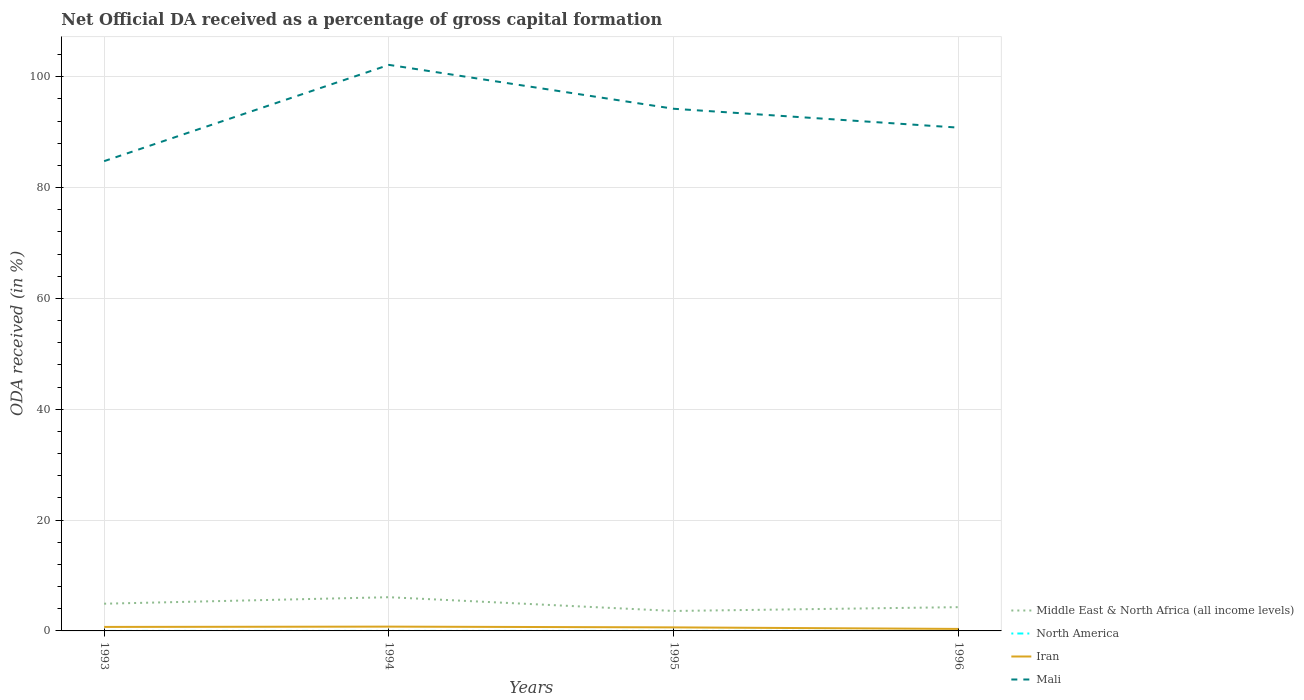Does the line corresponding to Middle East & North Africa (all income levels) intersect with the line corresponding to North America?
Your response must be concise. No. Across all years, what is the maximum net ODA received in Iran?
Give a very brief answer. 0.36. What is the total net ODA received in Middle East & North Africa (all income levels) in the graph?
Give a very brief answer. -1.17. What is the difference between the highest and the second highest net ODA received in Iran?
Your answer should be compact. 0.41. Is the net ODA received in Iran strictly greater than the net ODA received in North America over the years?
Keep it short and to the point. No. What is the difference between two consecutive major ticks on the Y-axis?
Provide a short and direct response. 20. Are the values on the major ticks of Y-axis written in scientific E-notation?
Make the answer very short. No. Does the graph contain any zero values?
Give a very brief answer. Yes. Where does the legend appear in the graph?
Your answer should be very brief. Bottom right. What is the title of the graph?
Keep it short and to the point. Net Official DA received as a percentage of gross capital formation. Does "Curacao" appear as one of the legend labels in the graph?
Give a very brief answer. No. What is the label or title of the Y-axis?
Ensure brevity in your answer.  ODA received (in %). What is the ODA received (in %) in Middle East & North Africa (all income levels) in 1993?
Offer a terse response. 4.91. What is the ODA received (in %) of Iran in 1993?
Make the answer very short. 0.72. What is the ODA received (in %) of Mali in 1993?
Your response must be concise. 84.77. What is the ODA received (in %) in Middle East & North Africa (all income levels) in 1994?
Provide a succinct answer. 6.08. What is the ODA received (in %) in North America in 1994?
Your answer should be compact. 0. What is the ODA received (in %) of Iran in 1994?
Make the answer very short. 0.77. What is the ODA received (in %) in Mali in 1994?
Give a very brief answer. 102.15. What is the ODA received (in %) in Middle East & North Africa (all income levels) in 1995?
Provide a succinct answer. 3.6. What is the ODA received (in %) of Iran in 1995?
Keep it short and to the point. 0.64. What is the ODA received (in %) in Mali in 1995?
Your response must be concise. 94.22. What is the ODA received (in %) of Middle East & North Africa (all income levels) in 1996?
Provide a succinct answer. 4.29. What is the ODA received (in %) of Iran in 1996?
Provide a succinct answer. 0.36. What is the ODA received (in %) of Mali in 1996?
Ensure brevity in your answer.  90.82. Across all years, what is the maximum ODA received (in %) in Middle East & North Africa (all income levels)?
Keep it short and to the point. 6.08. Across all years, what is the maximum ODA received (in %) of Iran?
Offer a very short reply. 0.77. Across all years, what is the maximum ODA received (in %) in Mali?
Your answer should be very brief. 102.15. Across all years, what is the minimum ODA received (in %) of Middle East & North Africa (all income levels)?
Your answer should be compact. 3.6. Across all years, what is the minimum ODA received (in %) of Iran?
Provide a succinct answer. 0.36. Across all years, what is the minimum ODA received (in %) in Mali?
Keep it short and to the point. 84.77. What is the total ODA received (in %) in Middle East & North Africa (all income levels) in the graph?
Keep it short and to the point. 18.89. What is the total ODA received (in %) of Iran in the graph?
Offer a terse response. 2.5. What is the total ODA received (in %) of Mali in the graph?
Provide a succinct answer. 371.96. What is the difference between the ODA received (in %) in Middle East & North Africa (all income levels) in 1993 and that in 1994?
Your answer should be compact. -1.17. What is the difference between the ODA received (in %) in Iran in 1993 and that in 1994?
Provide a succinct answer. -0.05. What is the difference between the ODA received (in %) of Mali in 1993 and that in 1994?
Provide a short and direct response. -17.37. What is the difference between the ODA received (in %) of Middle East & North Africa (all income levels) in 1993 and that in 1995?
Your response must be concise. 1.31. What is the difference between the ODA received (in %) in Iran in 1993 and that in 1995?
Offer a terse response. 0.08. What is the difference between the ODA received (in %) of Mali in 1993 and that in 1995?
Ensure brevity in your answer.  -9.45. What is the difference between the ODA received (in %) in Middle East & North Africa (all income levels) in 1993 and that in 1996?
Your answer should be compact. 0.62. What is the difference between the ODA received (in %) of Iran in 1993 and that in 1996?
Your answer should be compact. 0.36. What is the difference between the ODA received (in %) in Mali in 1993 and that in 1996?
Provide a short and direct response. -6.05. What is the difference between the ODA received (in %) of Middle East & North Africa (all income levels) in 1994 and that in 1995?
Make the answer very short. 2.48. What is the difference between the ODA received (in %) in Iran in 1994 and that in 1995?
Offer a very short reply. 0.13. What is the difference between the ODA received (in %) in Mali in 1994 and that in 1995?
Your answer should be very brief. 7.92. What is the difference between the ODA received (in %) of Middle East & North Africa (all income levels) in 1994 and that in 1996?
Ensure brevity in your answer.  1.8. What is the difference between the ODA received (in %) in Iran in 1994 and that in 1996?
Your answer should be very brief. 0.41. What is the difference between the ODA received (in %) in Mali in 1994 and that in 1996?
Provide a short and direct response. 11.33. What is the difference between the ODA received (in %) of Middle East & North Africa (all income levels) in 1995 and that in 1996?
Make the answer very short. -0.69. What is the difference between the ODA received (in %) of Iran in 1995 and that in 1996?
Make the answer very short. 0.28. What is the difference between the ODA received (in %) of Mali in 1995 and that in 1996?
Offer a terse response. 3.41. What is the difference between the ODA received (in %) of Middle East & North Africa (all income levels) in 1993 and the ODA received (in %) of Iran in 1994?
Your answer should be very brief. 4.14. What is the difference between the ODA received (in %) in Middle East & North Africa (all income levels) in 1993 and the ODA received (in %) in Mali in 1994?
Your response must be concise. -97.23. What is the difference between the ODA received (in %) in Iran in 1993 and the ODA received (in %) in Mali in 1994?
Ensure brevity in your answer.  -101.42. What is the difference between the ODA received (in %) in Middle East & North Africa (all income levels) in 1993 and the ODA received (in %) in Iran in 1995?
Make the answer very short. 4.27. What is the difference between the ODA received (in %) of Middle East & North Africa (all income levels) in 1993 and the ODA received (in %) of Mali in 1995?
Your answer should be very brief. -89.31. What is the difference between the ODA received (in %) of Iran in 1993 and the ODA received (in %) of Mali in 1995?
Make the answer very short. -93.5. What is the difference between the ODA received (in %) of Middle East & North Africa (all income levels) in 1993 and the ODA received (in %) of Iran in 1996?
Provide a short and direct response. 4.55. What is the difference between the ODA received (in %) in Middle East & North Africa (all income levels) in 1993 and the ODA received (in %) in Mali in 1996?
Your answer should be very brief. -85.91. What is the difference between the ODA received (in %) in Iran in 1993 and the ODA received (in %) in Mali in 1996?
Keep it short and to the point. -90.1. What is the difference between the ODA received (in %) in Middle East & North Africa (all income levels) in 1994 and the ODA received (in %) in Iran in 1995?
Make the answer very short. 5.44. What is the difference between the ODA received (in %) of Middle East & North Africa (all income levels) in 1994 and the ODA received (in %) of Mali in 1995?
Your response must be concise. -88.14. What is the difference between the ODA received (in %) of Iran in 1994 and the ODA received (in %) of Mali in 1995?
Provide a succinct answer. -93.45. What is the difference between the ODA received (in %) in Middle East & North Africa (all income levels) in 1994 and the ODA received (in %) in Iran in 1996?
Make the answer very short. 5.72. What is the difference between the ODA received (in %) of Middle East & North Africa (all income levels) in 1994 and the ODA received (in %) of Mali in 1996?
Give a very brief answer. -84.73. What is the difference between the ODA received (in %) in Iran in 1994 and the ODA received (in %) in Mali in 1996?
Your answer should be very brief. -90.04. What is the difference between the ODA received (in %) in Middle East & North Africa (all income levels) in 1995 and the ODA received (in %) in Iran in 1996?
Your answer should be compact. 3.24. What is the difference between the ODA received (in %) of Middle East & North Africa (all income levels) in 1995 and the ODA received (in %) of Mali in 1996?
Ensure brevity in your answer.  -87.22. What is the difference between the ODA received (in %) of Iran in 1995 and the ODA received (in %) of Mali in 1996?
Offer a terse response. -90.18. What is the average ODA received (in %) in Middle East & North Africa (all income levels) per year?
Offer a terse response. 4.72. What is the average ODA received (in %) of North America per year?
Make the answer very short. 0. What is the average ODA received (in %) of Iran per year?
Offer a terse response. 0.62. What is the average ODA received (in %) in Mali per year?
Provide a succinct answer. 92.99. In the year 1993, what is the difference between the ODA received (in %) in Middle East & North Africa (all income levels) and ODA received (in %) in Iran?
Ensure brevity in your answer.  4.19. In the year 1993, what is the difference between the ODA received (in %) of Middle East & North Africa (all income levels) and ODA received (in %) of Mali?
Provide a succinct answer. -79.86. In the year 1993, what is the difference between the ODA received (in %) of Iran and ODA received (in %) of Mali?
Offer a very short reply. -84.05. In the year 1994, what is the difference between the ODA received (in %) of Middle East & North Africa (all income levels) and ODA received (in %) of Iran?
Your answer should be very brief. 5.31. In the year 1994, what is the difference between the ODA received (in %) in Middle East & North Africa (all income levels) and ODA received (in %) in Mali?
Your answer should be compact. -96.06. In the year 1994, what is the difference between the ODA received (in %) of Iran and ODA received (in %) of Mali?
Give a very brief answer. -101.37. In the year 1995, what is the difference between the ODA received (in %) of Middle East & North Africa (all income levels) and ODA received (in %) of Iran?
Your answer should be compact. 2.96. In the year 1995, what is the difference between the ODA received (in %) in Middle East & North Africa (all income levels) and ODA received (in %) in Mali?
Your response must be concise. -90.62. In the year 1995, what is the difference between the ODA received (in %) of Iran and ODA received (in %) of Mali?
Provide a short and direct response. -93.58. In the year 1996, what is the difference between the ODA received (in %) in Middle East & North Africa (all income levels) and ODA received (in %) in Iran?
Provide a succinct answer. 3.93. In the year 1996, what is the difference between the ODA received (in %) of Middle East & North Africa (all income levels) and ODA received (in %) of Mali?
Keep it short and to the point. -86.53. In the year 1996, what is the difference between the ODA received (in %) of Iran and ODA received (in %) of Mali?
Ensure brevity in your answer.  -90.46. What is the ratio of the ODA received (in %) of Middle East & North Africa (all income levels) in 1993 to that in 1994?
Provide a succinct answer. 0.81. What is the ratio of the ODA received (in %) in Mali in 1993 to that in 1994?
Keep it short and to the point. 0.83. What is the ratio of the ODA received (in %) of Middle East & North Africa (all income levels) in 1993 to that in 1995?
Offer a very short reply. 1.36. What is the ratio of the ODA received (in %) of Iran in 1993 to that in 1995?
Offer a very short reply. 1.13. What is the ratio of the ODA received (in %) in Mali in 1993 to that in 1995?
Offer a very short reply. 0.9. What is the ratio of the ODA received (in %) of Middle East & North Africa (all income levels) in 1993 to that in 1996?
Your answer should be compact. 1.14. What is the ratio of the ODA received (in %) of Iran in 1993 to that in 1996?
Make the answer very short. 2. What is the ratio of the ODA received (in %) of Mali in 1993 to that in 1996?
Give a very brief answer. 0.93. What is the ratio of the ODA received (in %) in Middle East & North Africa (all income levels) in 1994 to that in 1995?
Your response must be concise. 1.69. What is the ratio of the ODA received (in %) of Iran in 1994 to that in 1995?
Your response must be concise. 1.21. What is the ratio of the ODA received (in %) in Mali in 1994 to that in 1995?
Your answer should be compact. 1.08. What is the ratio of the ODA received (in %) in Middle East & North Africa (all income levels) in 1994 to that in 1996?
Offer a terse response. 1.42. What is the ratio of the ODA received (in %) in Iran in 1994 to that in 1996?
Provide a short and direct response. 2.15. What is the ratio of the ODA received (in %) in Mali in 1994 to that in 1996?
Your answer should be very brief. 1.12. What is the ratio of the ODA received (in %) in Middle East & North Africa (all income levels) in 1995 to that in 1996?
Your answer should be very brief. 0.84. What is the ratio of the ODA received (in %) in Iran in 1995 to that in 1996?
Offer a terse response. 1.78. What is the ratio of the ODA received (in %) in Mali in 1995 to that in 1996?
Offer a very short reply. 1.04. What is the difference between the highest and the second highest ODA received (in %) of Middle East & North Africa (all income levels)?
Provide a succinct answer. 1.17. What is the difference between the highest and the second highest ODA received (in %) in Iran?
Provide a short and direct response. 0.05. What is the difference between the highest and the second highest ODA received (in %) of Mali?
Offer a very short reply. 7.92. What is the difference between the highest and the lowest ODA received (in %) in Middle East & North Africa (all income levels)?
Provide a succinct answer. 2.48. What is the difference between the highest and the lowest ODA received (in %) in Iran?
Keep it short and to the point. 0.41. What is the difference between the highest and the lowest ODA received (in %) in Mali?
Provide a succinct answer. 17.37. 